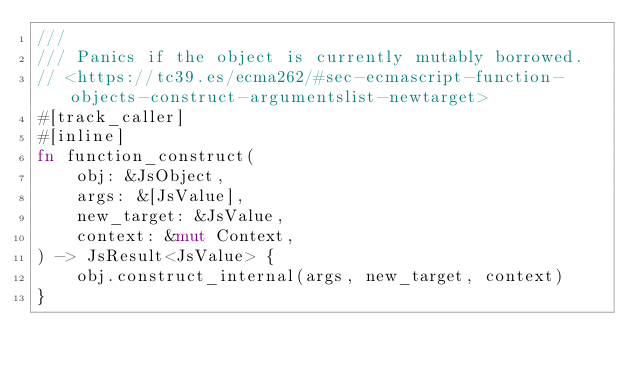<code> <loc_0><loc_0><loc_500><loc_500><_Rust_>///
/// Panics if the object is currently mutably borrowed.
// <https://tc39.es/ecma262/#sec-ecmascript-function-objects-construct-argumentslist-newtarget>
#[track_caller]
#[inline]
fn function_construct(
    obj: &JsObject,
    args: &[JsValue],
    new_target: &JsValue,
    context: &mut Context,
) -> JsResult<JsValue> {
    obj.construct_internal(args, new_target, context)
}
</code> 